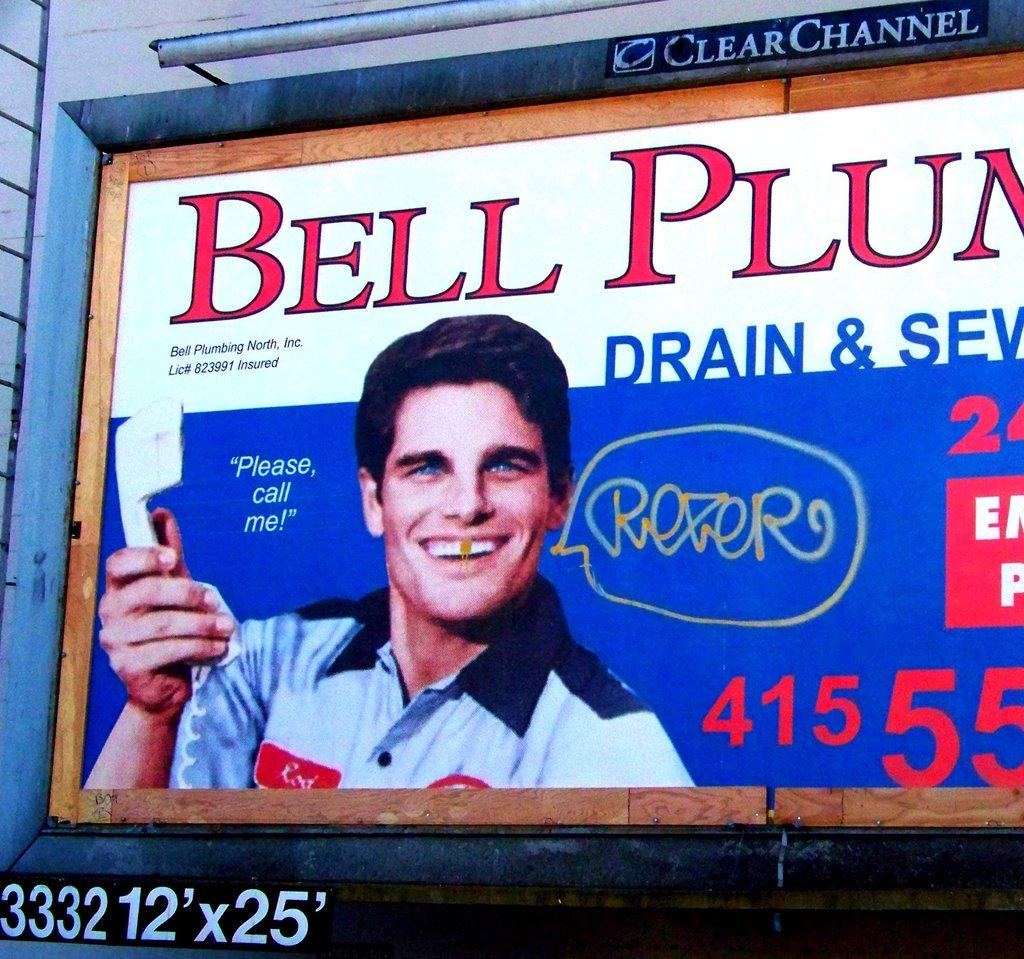What is the man quoted in saying?
Your answer should be very brief. Please call me. 